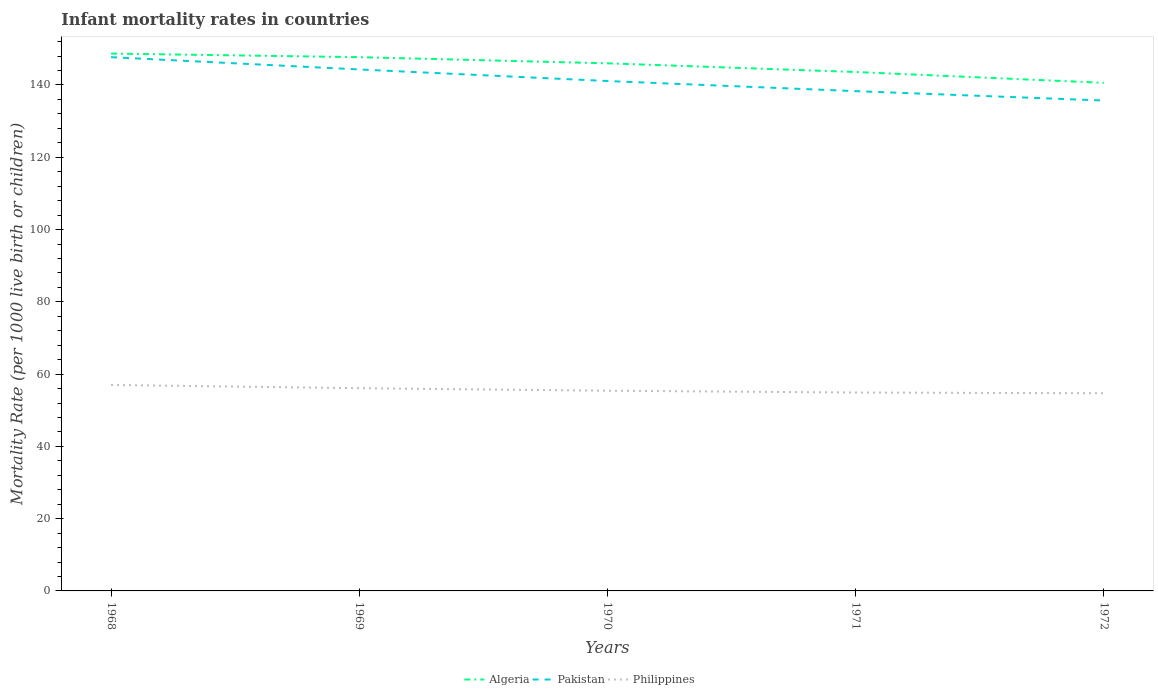Does the line corresponding to Philippines intersect with the line corresponding to Algeria?
Offer a very short reply. No. Across all years, what is the maximum infant mortality rate in Pakistan?
Your answer should be very brief. 135.7. What is the total infant mortality rate in Pakistan in the graph?
Offer a very short reply. 2.8. What is the difference between the highest and the second highest infant mortality rate in Philippines?
Your response must be concise. 2.3. What is the difference between the highest and the lowest infant mortality rate in Pakistan?
Your response must be concise. 2. What is the difference between two consecutive major ticks on the Y-axis?
Your answer should be compact. 20. Does the graph contain grids?
Offer a very short reply. No. How many legend labels are there?
Make the answer very short. 3. How are the legend labels stacked?
Make the answer very short. Horizontal. What is the title of the graph?
Your response must be concise. Infant mortality rates in countries. Does "Botswana" appear as one of the legend labels in the graph?
Ensure brevity in your answer.  No. What is the label or title of the Y-axis?
Offer a terse response. Mortality Rate (per 1000 live birth or children). What is the Mortality Rate (per 1000 live birth or children) of Algeria in 1968?
Offer a terse response. 148.7. What is the Mortality Rate (per 1000 live birth or children) of Pakistan in 1968?
Provide a short and direct response. 147.7. What is the Mortality Rate (per 1000 live birth or children) in Philippines in 1968?
Provide a short and direct response. 57. What is the Mortality Rate (per 1000 live birth or children) of Algeria in 1969?
Your answer should be compact. 147.7. What is the Mortality Rate (per 1000 live birth or children) in Pakistan in 1969?
Make the answer very short. 144.3. What is the Mortality Rate (per 1000 live birth or children) of Philippines in 1969?
Give a very brief answer. 56.1. What is the Mortality Rate (per 1000 live birth or children) of Algeria in 1970?
Ensure brevity in your answer.  146. What is the Mortality Rate (per 1000 live birth or children) in Pakistan in 1970?
Your response must be concise. 141.1. What is the Mortality Rate (per 1000 live birth or children) in Philippines in 1970?
Keep it short and to the point. 55.4. What is the Mortality Rate (per 1000 live birth or children) in Algeria in 1971?
Your response must be concise. 143.6. What is the Mortality Rate (per 1000 live birth or children) of Pakistan in 1971?
Make the answer very short. 138.3. What is the Mortality Rate (per 1000 live birth or children) of Philippines in 1971?
Make the answer very short. 54.9. What is the Mortality Rate (per 1000 live birth or children) of Algeria in 1972?
Provide a short and direct response. 140.6. What is the Mortality Rate (per 1000 live birth or children) in Pakistan in 1972?
Keep it short and to the point. 135.7. What is the Mortality Rate (per 1000 live birth or children) of Philippines in 1972?
Your response must be concise. 54.7. Across all years, what is the maximum Mortality Rate (per 1000 live birth or children) of Algeria?
Make the answer very short. 148.7. Across all years, what is the maximum Mortality Rate (per 1000 live birth or children) in Pakistan?
Ensure brevity in your answer.  147.7. Across all years, what is the minimum Mortality Rate (per 1000 live birth or children) of Algeria?
Your answer should be very brief. 140.6. Across all years, what is the minimum Mortality Rate (per 1000 live birth or children) in Pakistan?
Give a very brief answer. 135.7. Across all years, what is the minimum Mortality Rate (per 1000 live birth or children) of Philippines?
Make the answer very short. 54.7. What is the total Mortality Rate (per 1000 live birth or children) of Algeria in the graph?
Your response must be concise. 726.6. What is the total Mortality Rate (per 1000 live birth or children) in Pakistan in the graph?
Your answer should be very brief. 707.1. What is the total Mortality Rate (per 1000 live birth or children) of Philippines in the graph?
Provide a short and direct response. 278.1. What is the difference between the Mortality Rate (per 1000 live birth or children) in Algeria in 1968 and that in 1969?
Offer a terse response. 1. What is the difference between the Mortality Rate (per 1000 live birth or children) of Pakistan in 1968 and that in 1970?
Make the answer very short. 6.6. What is the difference between the Mortality Rate (per 1000 live birth or children) of Philippines in 1968 and that in 1970?
Your answer should be very brief. 1.6. What is the difference between the Mortality Rate (per 1000 live birth or children) of Algeria in 1968 and that in 1971?
Offer a terse response. 5.1. What is the difference between the Mortality Rate (per 1000 live birth or children) of Pakistan in 1968 and that in 1972?
Ensure brevity in your answer.  12. What is the difference between the Mortality Rate (per 1000 live birth or children) of Pakistan in 1969 and that in 1970?
Your response must be concise. 3.2. What is the difference between the Mortality Rate (per 1000 live birth or children) of Philippines in 1969 and that in 1970?
Your response must be concise. 0.7. What is the difference between the Mortality Rate (per 1000 live birth or children) of Pakistan in 1969 and that in 1971?
Offer a terse response. 6. What is the difference between the Mortality Rate (per 1000 live birth or children) of Philippines in 1969 and that in 1971?
Your response must be concise. 1.2. What is the difference between the Mortality Rate (per 1000 live birth or children) in Pakistan in 1969 and that in 1972?
Provide a succinct answer. 8.6. What is the difference between the Mortality Rate (per 1000 live birth or children) in Algeria in 1970 and that in 1971?
Give a very brief answer. 2.4. What is the difference between the Mortality Rate (per 1000 live birth or children) of Pakistan in 1970 and that in 1971?
Make the answer very short. 2.8. What is the difference between the Mortality Rate (per 1000 live birth or children) of Algeria in 1970 and that in 1972?
Make the answer very short. 5.4. What is the difference between the Mortality Rate (per 1000 live birth or children) of Pakistan in 1970 and that in 1972?
Offer a very short reply. 5.4. What is the difference between the Mortality Rate (per 1000 live birth or children) in Philippines in 1970 and that in 1972?
Provide a short and direct response. 0.7. What is the difference between the Mortality Rate (per 1000 live birth or children) in Algeria in 1971 and that in 1972?
Ensure brevity in your answer.  3. What is the difference between the Mortality Rate (per 1000 live birth or children) in Pakistan in 1971 and that in 1972?
Make the answer very short. 2.6. What is the difference between the Mortality Rate (per 1000 live birth or children) in Philippines in 1971 and that in 1972?
Your response must be concise. 0.2. What is the difference between the Mortality Rate (per 1000 live birth or children) of Algeria in 1968 and the Mortality Rate (per 1000 live birth or children) of Pakistan in 1969?
Your response must be concise. 4.4. What is the difference between the Mortality Rate (per 1000 live birth or children) in Algeria in 1968 and the Mortality Rate (per 1000 live birth or children) in Philippines in 1969?
Give a very brief answer. 92.6. What is the difference between the Mortality Rate (per 1000 live birth or children) of Pakistan in 1968 and the Mortality Rate (per 1000 live birth or children) of Philippines in 1969?
Make the answer very short. 91.6. What is the difference between the Mortality Rate (per 1000 live birth or children) of Algeria in 1968 and the Mortality Rate (per 1000 live birth or children) of Philippines in 1970?
Give a very brief answer. 93.3. What is the difference between the Mortality Rate (per 1000 live birth or children) of Pakistan in 1968 and the Mortality Rate (per 1000 live birth or children) of Philippines in 1970?
Your answer should be compact. 92.3. What is the difference between the Mortality Rate (per 1000 live birth or children) in Algeria in 1968 and the Mortality Rate (per 1000 live birth or children) in Pakistan in 1971?
Ensure brevity in your answer.  10.4. What is the difference between the Mortality Rate (per 1000 live birth or children) in Algeria in 1968 and the Mortality Rate (per 1000 live birth or children) in Philippines in 1971?
Ensure brevity in your answer.  93.8. What is the difference between the Mortality Rate (per 1000 live birth or children) in Pakistan in 1968 and the Mortality Rate (per 1000 live birth or children) in Philippines in 1971?
Provide a short and direct response. 92.8. What is the difference between the Mortality Rate (per 1000 live birth or children) in Algeria in 1968 and the Mortality Rate (per 1000 live birth or children) in Philippines in 1972?
Your response must be concise. 94. What is the difference between the Mortality Rate (per 1000 live birth or children) in Pakistan in 1968 and the Mortality Rate (per 1000 live birth or children) in Philippines in 1972?
Provide a succinct answer. 93. What is the difference between the Mortality Rate (per 1000 live birth or children) in Algeria in 1969 and the Mortality Rate (per 1000 live birth or children) in Philippines in 1970?
Make the answer very short. 92.3. What is the difference between the Mortality Rate (per 1000 live birth or children) in Pakistan in 1969 and the Mortality Rate (per 1000 live birth or children) in Philippines in 1970?
Make the answer very short. 88.9. What is the difference between the Mortality Rate (per 1000 live birth or children) of Algeria in 1969 and the Mortality Rate (per 1000 live birth or children) of Pakistan in 1971?
Ensure brevity in your answer.  9.4. What is the difference between the Mortality Rate (per 1000 live birth or children) of Algeria in 1969 and the Mortality Rate (per 1000 live birth or children) of Philippines in 1971?
Give a very brief answer. 92.8. What is the difference between the Mortality Rate (per 1000 live birth or children) of Pakistan in 1969 and the Mortality Rate (per 1000 live birth or children) of Philippines in 1971?
Your answer should be very brief. 89.4. What is the difference between the Mortality Rate (per 1000 live birth or children) in Algeria in 1969 and the Mortality Rate (per 1000 live birth or children) in Philippines in 1972?
Keep it short and to the point. 93. What is the difference between the Mortality Rate (per 1000 live birth or children) in Pakistan in 1969 and the Mortality Rate (per 1000 live birth or children) in Philippines in 1972?
Ensure brevity in your answer.  89.6. What is the difference between the Mortality Rate (per 1000 live birth or children) of Algeria in 1970 and the Mortality Rate (per 1000 live birth or children) of Philippines in 1971?
Offer a very short reply. 91.1. What is the difference between the Mortality Rate (per 1000 live birth or children) in Pakistan in 1970 and the Mortality Rate (per 1000 live birth or children) in Philippines in 1971?
Offer a very short reply. 86.2. What is the difference between the Mortality Rate (per 1000 live birth or children) in Algeria in 1970 and the Mortality Rate (per 1000 live birth or children) in Pakistan in 1972?
Give a very brief answer. 10.3. What is the difference between the Mortality Rate (per 1000 live birth or children) in Algeria in 1970 and the Mortality Rate (per 1000 live birth or children) in Philippines in 1972?
Your answer should be very brief. 91.3. What is the difference between the Mortality Rate (per 1000 live birth or children) of Pakistan in 1970 and the Mortality Rate (per 1000 live birth or children) of Philippines in 1972?
Offer a very short reply. 86.4. What is the difference between the Mortality Rate (per 1000 live birth or children) in Algeria in 1971 and the Mortality Rate (per 1000 live birth or children) in Philippines in 1972?
Make the answer very short. 88.9. What is the difference between the Mortality Rate (per 1000 live birth or children) of Pakistan in 1971 and the Mortality Rate (per 1000 live birth or children) of Philippines in 1972?
Keep it short and to the point. 83.6. What is the average Mortality Rate (per 1000 live birth or children) of Algeria per year?
Give a very brief answer. 145.32. What is the average Mortality Rate (per 1000 live birth or children) of Pakistan per year?
Provide a succinct answer. 141.42. What is the average Mortality Rate (per 1000 live birth or children) in Philippines per year?
Provide a succinct answer. 55.62. In the year 1968, what is the difference between the Mortality Rate (per 1000 live birth or children) of Algeria and Mortality Rate (per 1000 live birth or children) of Philippines?
Provide a short and direct response. 91.7. In the year 1968, what is the difference between the Mortality Rate (per 1000 live birth or children) in Pakistan and Mortality Rate (per 1000 live birth or children) in Philippines?
Your response must be concise. 90.7. In the year 1969, what is the difference between the Mortality Rate (per 1000 live birth or children) in Algeria and Mortality Rate (per 1000 live birth or children) in Philippines?
Keep it short and to the point. 91.6. In the year 1969, what is the difference between the Mortality Rate (per 1000 live birth or children) of Pakistan and Mortality Rate (per 1000 live birth or children) of Philippines?
Give a very brief answer. 88.2. In the year 1970, what is the difference between the Mortality Rate (per 1000 live birth or children) in Algeria and Mortality Rate (per 1000 live birth or children) in Philippines?
Keep it short and to the point. 90.6. In the year 1970, what is the difference between the Mortality Rate (per 1000 live birth or children) of Pakistan and Mortality Rate (per 1000 live birth or children) of Philippines?
Make the answer very short. 85.7. In the year 1971, what is the difference between the Mortality Rate (per 1000 live birth or children) of Algeria and Mortality Rate (per 1000 live birth or children) of Philippines?
Make the answer very short. 88.7. In the year 1971, what is the difference between the Mortality Rate (per 1000 live birth or children) of Pakistan and Mortality Rate (per 1000 live birth or children) of Philippines?
Your response must be concise. 83.4. In the year 1972, what is the difference between the Mortality Rate (per 1000 live birth or children) of Algeria and Mortality Rate (per 1000 live birth or children) of Pakistan?
Provide a short and direct response. 4.9. In the year 1972, what is the difference between the Mortality Rate (per 1000 live birth or children) in Algeria and Mortality Rate (per 1000 live birth or children) in Philippines?
Offer a terse response. 85.9. In the year 1972, what is the difference between the Mortality Rate (per 1000 live birth or children) of Pakistan and Mortality Rate (per 1000 live birth or children) of Philippines?
Make the answer very short. 81. What is the ratio of the Mortality Rate (per 1000 live birth or children) of Algeria in 1968 to that in 1969?
Offer a very short reply. 1.01. What is the ratio of the Mortality Rate (per 1000 live birth or children) of Pakistan in 1968 to that in 1969?
Keep it short and to the point. 1.02. What is the ratio of the Mortality Rate (per 1000 live birth or children) of Philippines in 1968 to that in 1969?
Your answer should be very brief. 1.02. What is the ratio of the Mortality Rate (per 1000 live birth or children) in Algeria in 1968 to that in 1970?
Provide a short and direct response. 1.02. What is the ratio of the Mortality Rate (per 1000 live birth or children) in Pakistan in 1968 to that in 1970?
Your answer should be compact. 1.05. What is the ratio of the Mortality Rate (per 1000 live birth or children) in Philippines in 1968 to that in 1970?
Ensure brevity in your answer.  1.03. What is the ratio of the Mortality Rate (per 1000 live birth or children) of Algeria in 1968 to that in 1971?
Offer a terse response. 1.04. What is the ratio of the Mortality Rate (per 1000 live birth or children) of Pakistan in 1968 to that in 1971?
Your answer should be very brief. 1.07. What is the ratio of the Mortality Rate (per 1000 live birth or children) of Philippines in 1968 to that in 1971?
Give a very brief answer. 1.04. What is the ratio of the Mortality Rate (per 1000 live birth or children) of Algeria in 1968 to that in 1972?
Provide a succinct answer. 1.06. What is the ratio of the Mortality Rate (per 1000 live birth or children) in Pakistan in 1968 to that in 1972?
Your answer should be very brief. 1.09. What is the ratio of the Mortality Rate (per 1000 live birth or children) of Philippines in 1968 to that in 1972?
Make the answer very short. 1.04. What is the ratio of the Mortality Rate (per 1000 live birth or children) in Algeria in 1969 to that in 1970?
Your response must be concise. 1.01. What is the ratio of the Mortality Rate (per 1000 live birth or children) in Pakistan in 1969 to that in 1970?
Your answer should be very brief. 1.02. What is the ratio of the Mortality Rate (per 1000 live birth or children) of Philippines in 1969 to that in 1970?
Make the answer very short. 1.01. What is the ratio of the Mortality Rate (per 1000 live birth or children) of Algeria in 1969 to that in 1971?
Give a very brief answer. 1.03. What is the ratio of the Mortality Rate (per 1000 live birth or children) in Pakistan in 1969 to that in 1971?
Give a very brief answer. 1.04. What is the ratio of the Mortality Rate (per 1000 live birth or children) in Philippines in 1969 to that in 1971?
Your answer should be very brief. 1.02. What is the ratio of the Mortality Rate (per 1000 live birth or children) of Algeria in 1969 to that in 1972?
Offer a terse response. 1.05. What is the ratio of the Mortality Rate (per 1000 live birth or children) in Pakistan in 1969 to that in 1972?
Your response must be concise. 1.06. What is the ratio of the Mortality Rate (per 1000 live birth or children) of Philippines in 1969 to that in 1972?
Keep it short and to the point. 1.03. What is the ratio of the Mortality Rate (per 1000 live birth or children) of Algeria in 1970 to that in 1971?
Ensure brevity in your answer.  1.02. What is the ratio of the Mortality Rate (per 1000 live birth or children) of Pakistan in 1970 to that in 1971?
Keep it short and to the point. 1.02. What is the ratio of the Mortality Rate (per 1000 live birth or children) of Philippines in 1970 to that in 1971?
Give a very brief answer. 1.01. What is the ratio of the Mortality Rate (per 1000 live birth or children) of Algeria in 1970 to that in 1972?
Provide a succinct answer. 1.04. What is the ratio of the Mortality Rate (per 1000 live birth or children) in Pakistan in 1970 to that in 1972?
Keep it short and to the point. 1.04. What is the ratio of the Mortality Rate (per 1000 live birth or children) in Philippines in 1970 to that in 1972?
Offer a terse response. 1.01. What is the ratio of the Mortality Rate (per 1000 live birth or children) of Algeria in 1971 to that in 1972?
Your response must be concise. 1.02. What is the ratio of the Mortality Rate (per 1000 live birth or children) in Pakistan in 1971 to that in 1972?
Make the answer very short. 1.02. What is the difference between the highest and the second highest Mortality Rate (per 1000 live birth or children) in Pakistan?
Provide a succinct answer. 3.4. 